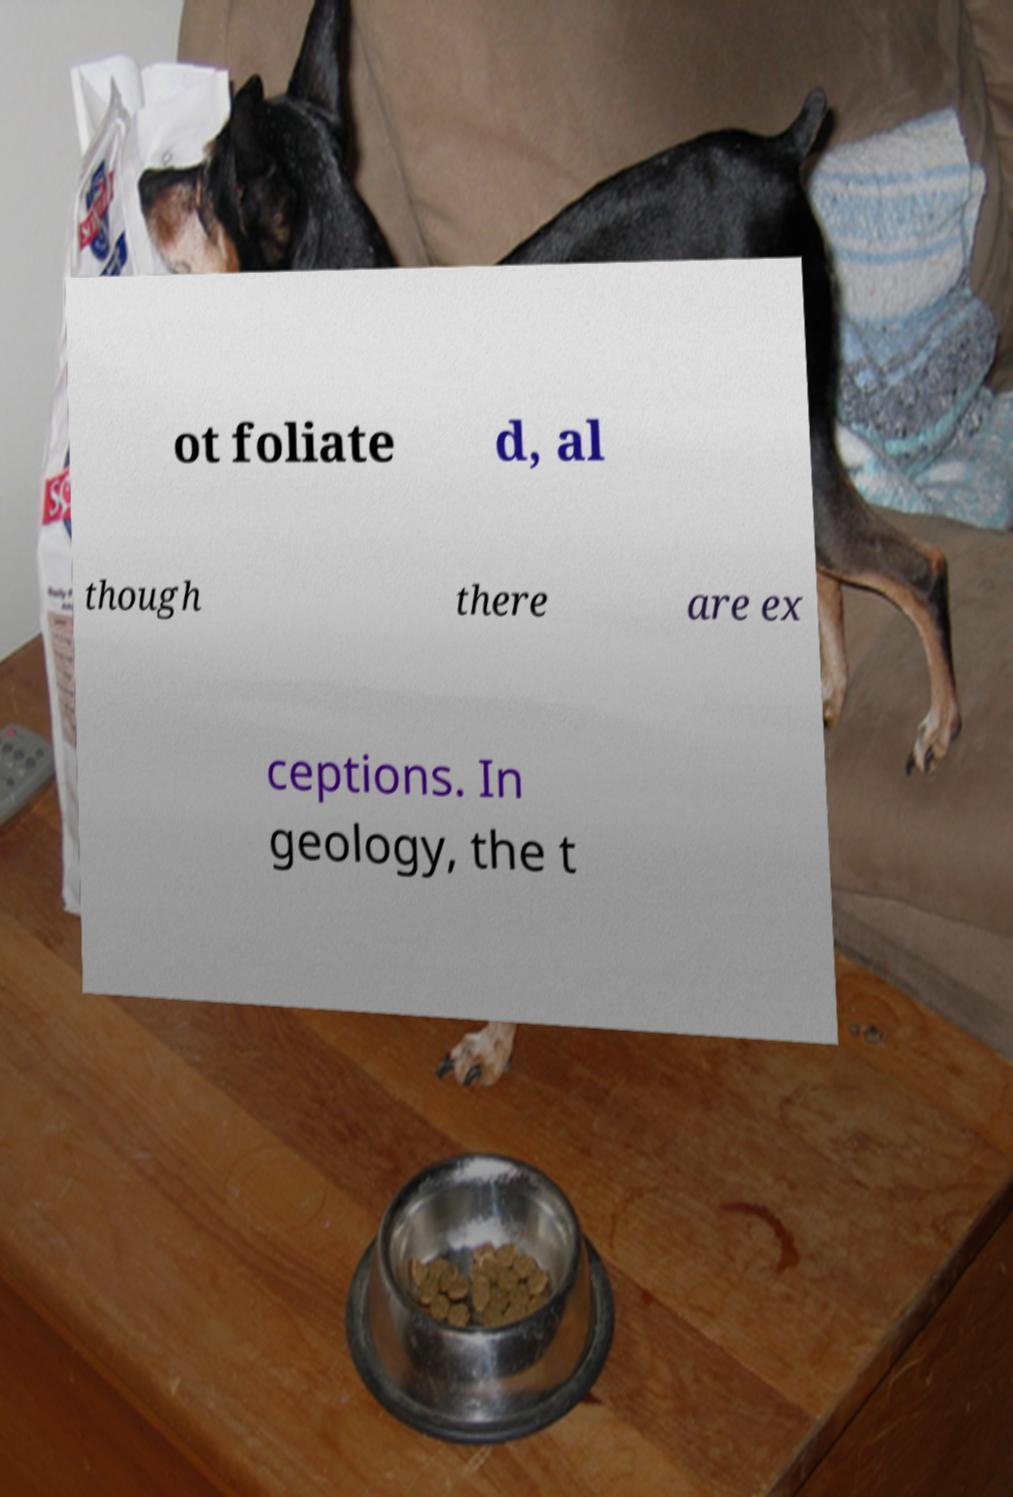For documentation purposes, I need the text within this image transcribed. Could you provide that? ot foliate d, al though there are ex ceptions. In geology, the t 